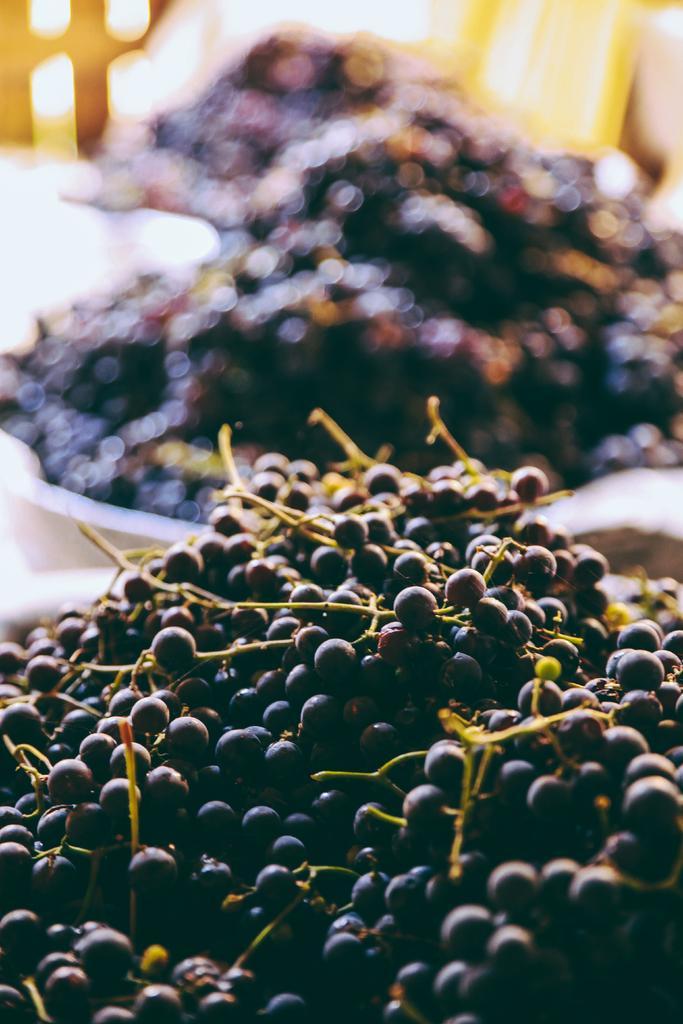In one or two sentences, can you explain what this image depicts? In this image in the foreground there are some grapes, and in the background there are some plates. And in the plates there are grapes, and the background is blurred. 